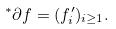<formula> <loc_0><loc_0><loc_500><loc_500>^ { * } \partial f = ( f ^ { \prime } _ { i } ) _ { i \geq 1 } .</formula> 